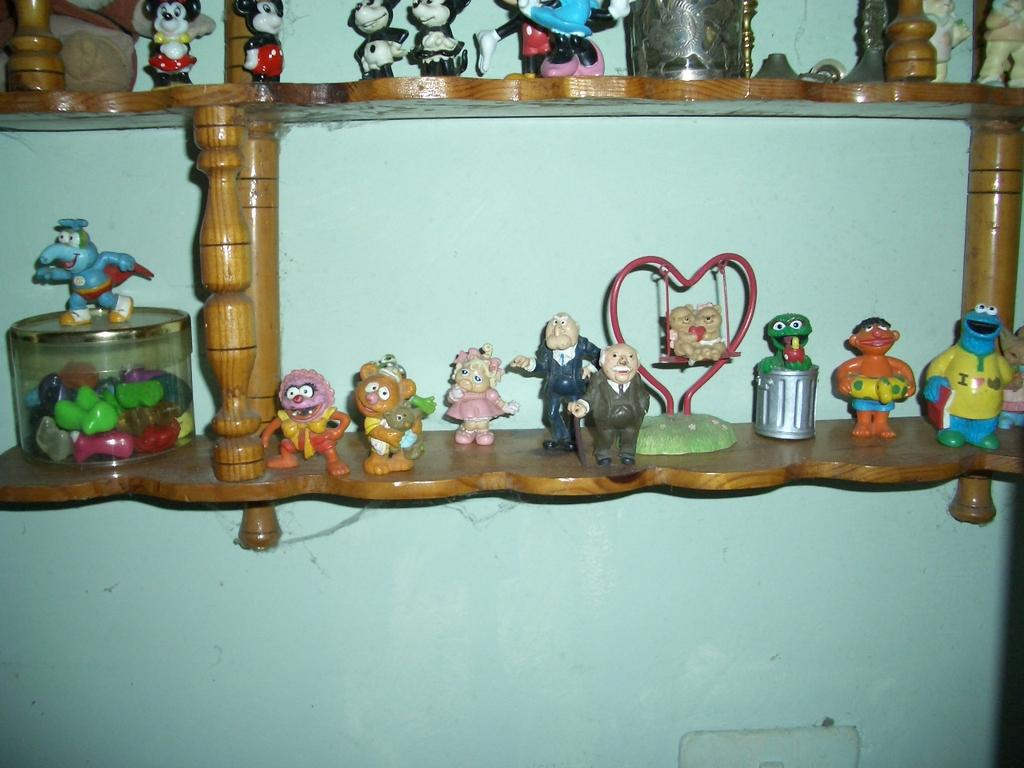What objects can be seen in the image? There are toys in the image. How are the toys arranged? The toys are arranged in a wooden rack. Where is the wooden rack located? The wooden rack is hanging on a wall. What type of quilt is draped over the toys in the image? There is no quilt present in the image; it only features toys arranged in a wooden rack hanging on a wall. 